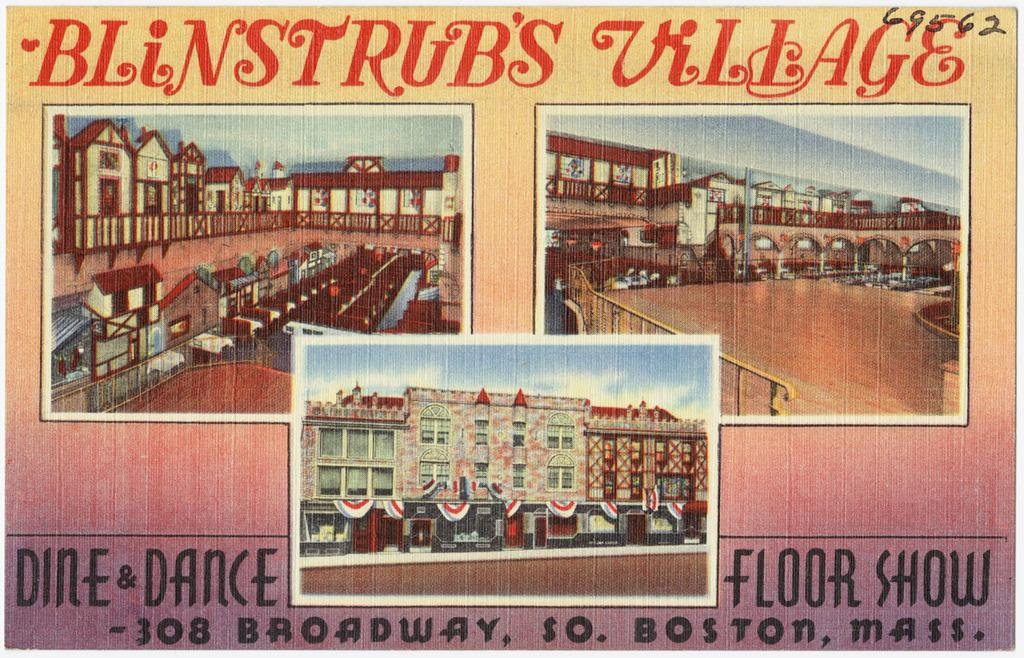Provide a one-sentence caption for the provided image. An advertisement poster for Blinstrub's Village in Boston, Massachusetts. 